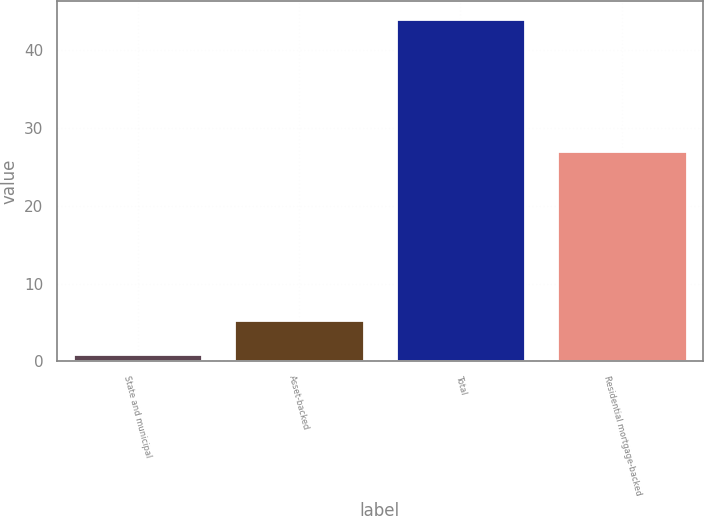<chart> <loc_0><loc_0><loc_500><loc_500><bar_chart><fcel>State and municipal<fcel>Asset-backed<fcel>Total<fcel>Residential mortgage-backed<nl><fcel>1<fcel>5.3<fcel>44<fcel>27<nl></chart> 